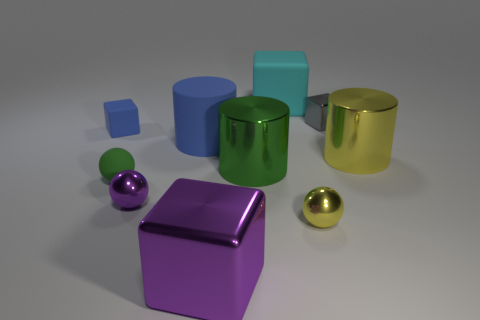Subtract all yellow blocks. Subtract all red spheres. How many blocks are left? 4 Subtract all cylinders. How many objects are left? 7 Add 7 rubber cylinders. How many rubber cylinders are left? 8 Add 9 tiny gray blocks. How many tiny gray blocks exist? 10 Subtract 0 cyan balls. How many objects are left? 10 Subtract all gray objects. Subtract all tiny yellow metallic spheres. How many objects are left? 8 